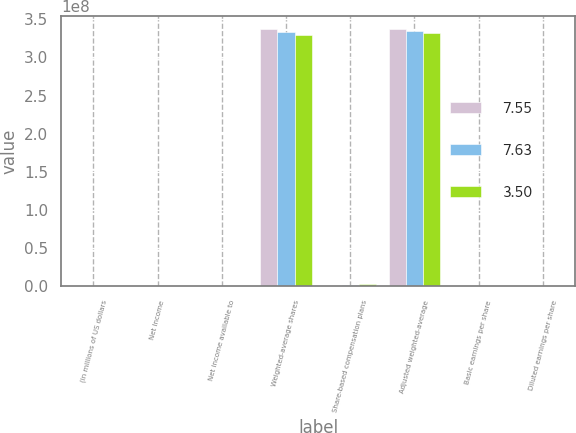Convert chart. <chart><loc_0><loc_0><loc_500><loc_500><stacked_bar_chart><ecel><fcel>(in millions of US dollars<fcel>Net Income<fcel>Net income available to<fcel>Weighted-average shares<fcel>Share-based compensation plans<fcel>Adjusted weighted-average<fcel>Basic earnings per share<fcel>Diluted earnings per share<nl><fcel>7.55<fcel>2009<fcel>2549<fcel>2549<fcel>3.36726e+08<fcel>813669<fcel>3.37539e+08<fcel>7.57<fcel>7.55<nl><fcel>7.63<fcel>2008<fcel>1197<fcel>1173<fcel>3.32901e+08<fcel>1.70552e+06<fcel>3.34606e+08<fcel>3.52<fcel>3.5<nl><fcel>3.5<fcel>2007<fcel>2578<fcel>2533<fcel>3.2899e+08<fcel>2.99877e+06<fcel>3.31989e+08<fcel>7.7<fcel>7.63<nl></chart> 